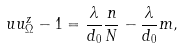Convert formula to latex. <formula><loc_0><loc_0><loc_500><loc_500>\ u u ^ { z } _ { \Omega } - 1 = \frac { \lambda } { d _ { 0 } } \frac { n } { N } - \frac { \lambda } { d _ { 0 } } m ,</formula> 